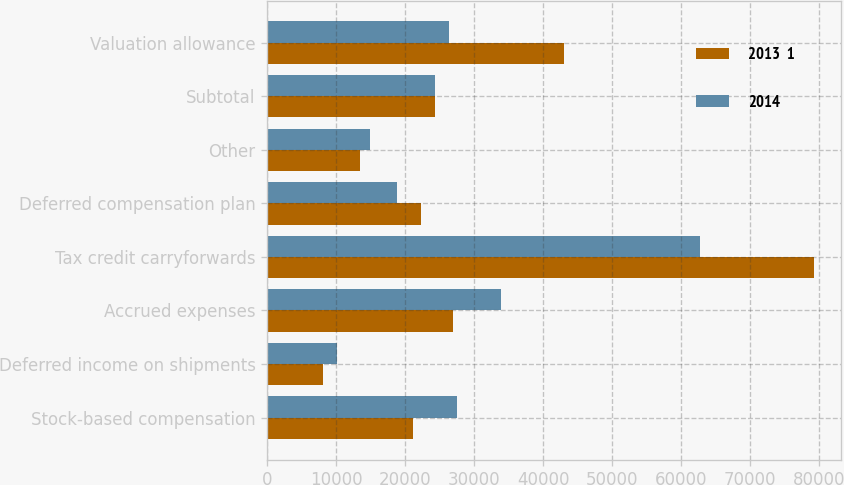Convert chart. <chart><loc_0><loc_0><loc_500><loc_500><stacked_bar_chart><ecel><fcel>Stock-based compensation<fcel>Deferred income on shipments<fcel>Accrued expenses<fcel>Tax credit carryforwards<fcel>Deferred compensation plan<fcel>Other<fcel>Subtotal<fcel>Valuation allowance<nl><fcel>2013  1<fcel>21142<fcel>8097<fcel>26864<fcel>79272<fcel>22280<fcel>13420<fcel>24340.5<fcel>43004<nl><fcel>2014<fcel>27481<fcel>10043<fcel>33859<fcel>62723<fcel>18769<fcel>14948<fcel>24340.5<fcel>26401<nl></chart> 